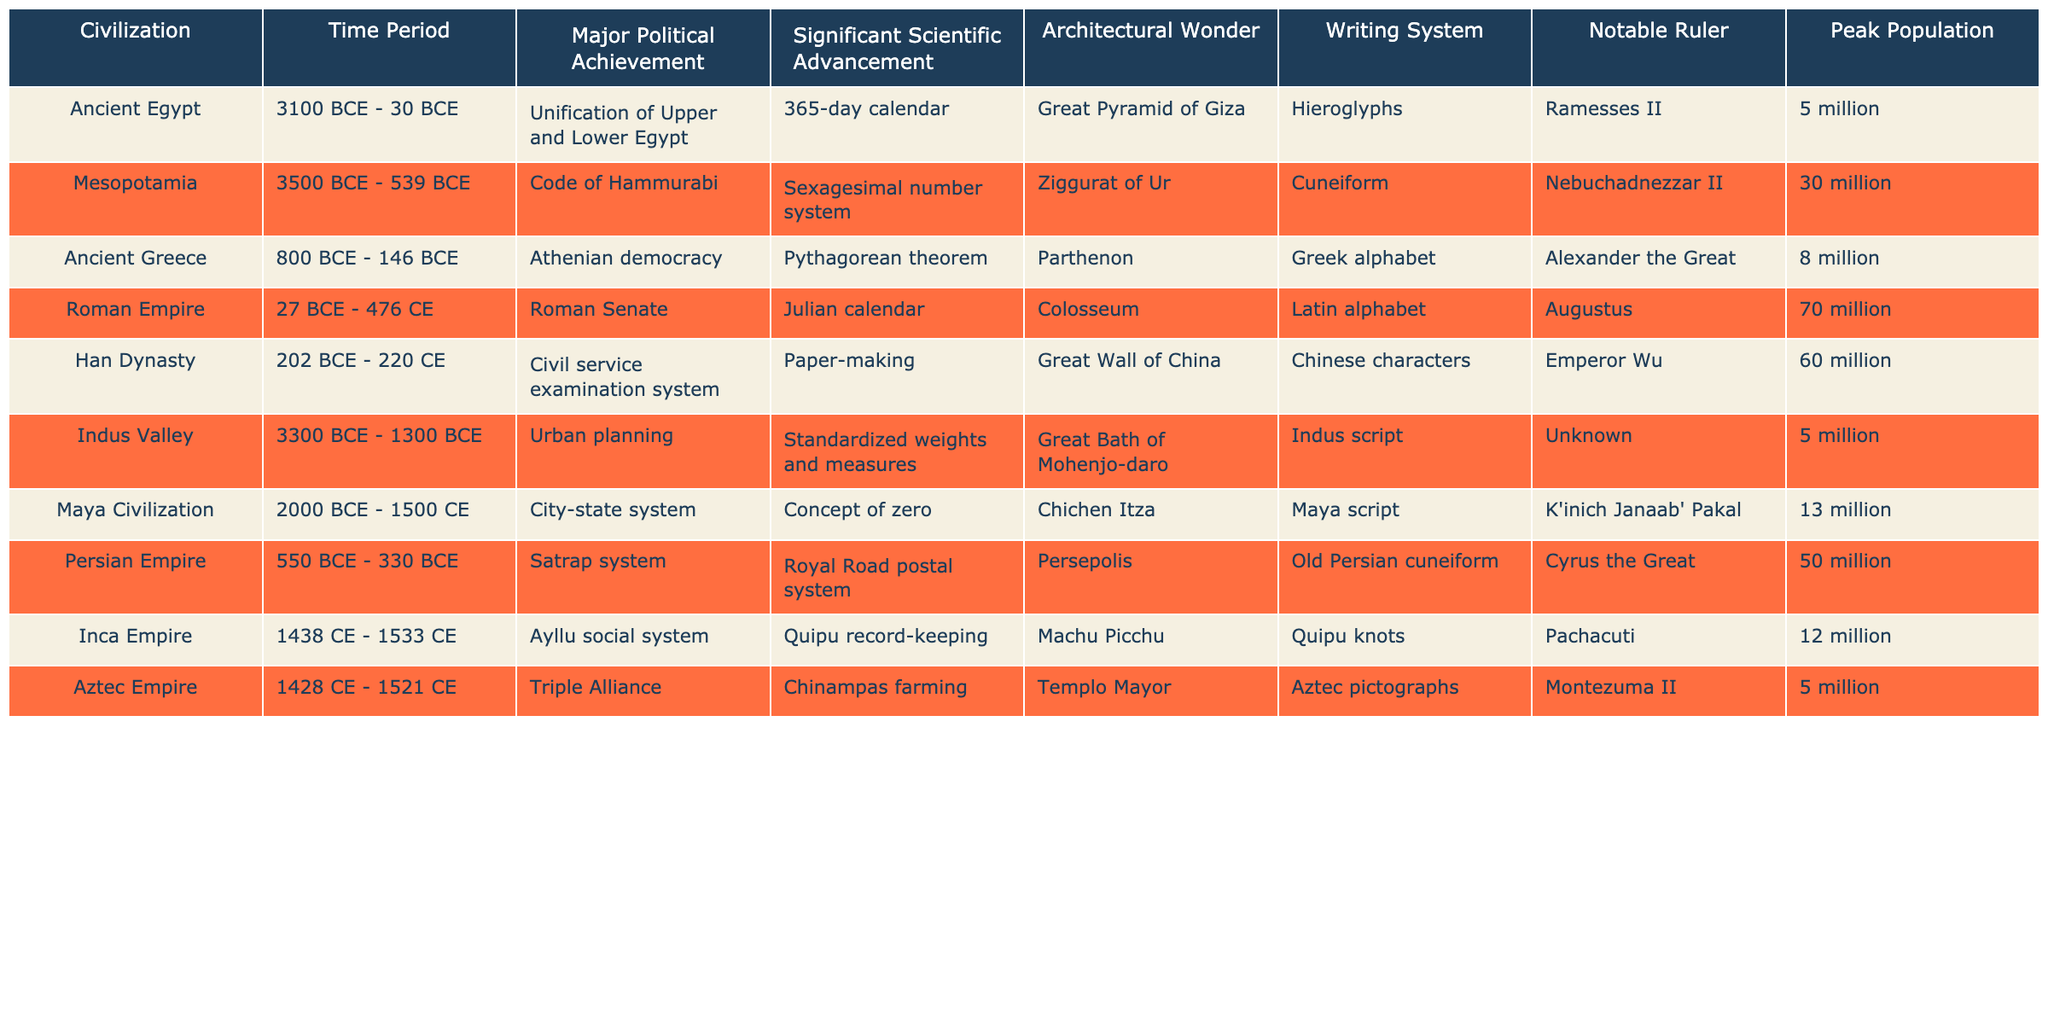What is the time period of the Roman Empire? The table specifies that the Roman Empire existed from 27 BCE to 476 CE.
Answer: 27 BCE - 476 CE Which civilization had the highest peak population? By checking the "Peak Population" column, the Roman Empire has 70 million, which is the highest.
Answer: Roman Empire Did the Maya Civilization develop a writing system? The table lists the writing system of the Maya Civilization as the Maya script, indicating that they did have a writing system.
Answer: Yes What is the architectural wonder associated with the Inca Empire? Referring to the table, the architectural wonder associated with the Inca Empire is Machu Picchu.
Answer: Machu Picchu How many civilizations had a peak population of 5 million? By reviewing the "Peak Population" column, the Indus Valley, Aztec Empire, and Ancient Egypt each have a peak population of 5 million, totaling 3 civilizations.
Answer: 3 What major political achievement did the Persian Empire have? According to the table, the Persian Empire is noted for having a Satrap system as its major political achievement.
Answer: Satrap system If you combine the peak populations of the Han Dynasty and the Maya Civilization, what is the total? The Han Dynasty has a peak population of 60 million and the Maya Civilization has 13 million, so the total is 60 + 13 = 73 million.
Answer: 73 million Which civilization is noted for using the cuneiform writing system? The table lists Mesopotamia as having the cuneiform writing system.
Answer: Mesopotamia Was the concept of zero developed before the common era? Since the table states that the concept of zero was a scientific advancement of the Maya Civilization, which started in 2000 BCE, it was indeed developed before the common era.
Answer: Yes Which civilization had both urban planning and a standardized weights and measures advancement? The Indus Valley is noted for having major scientific advancements in both urban planning and standardized weights and measures.
Answer: Indus Valley 